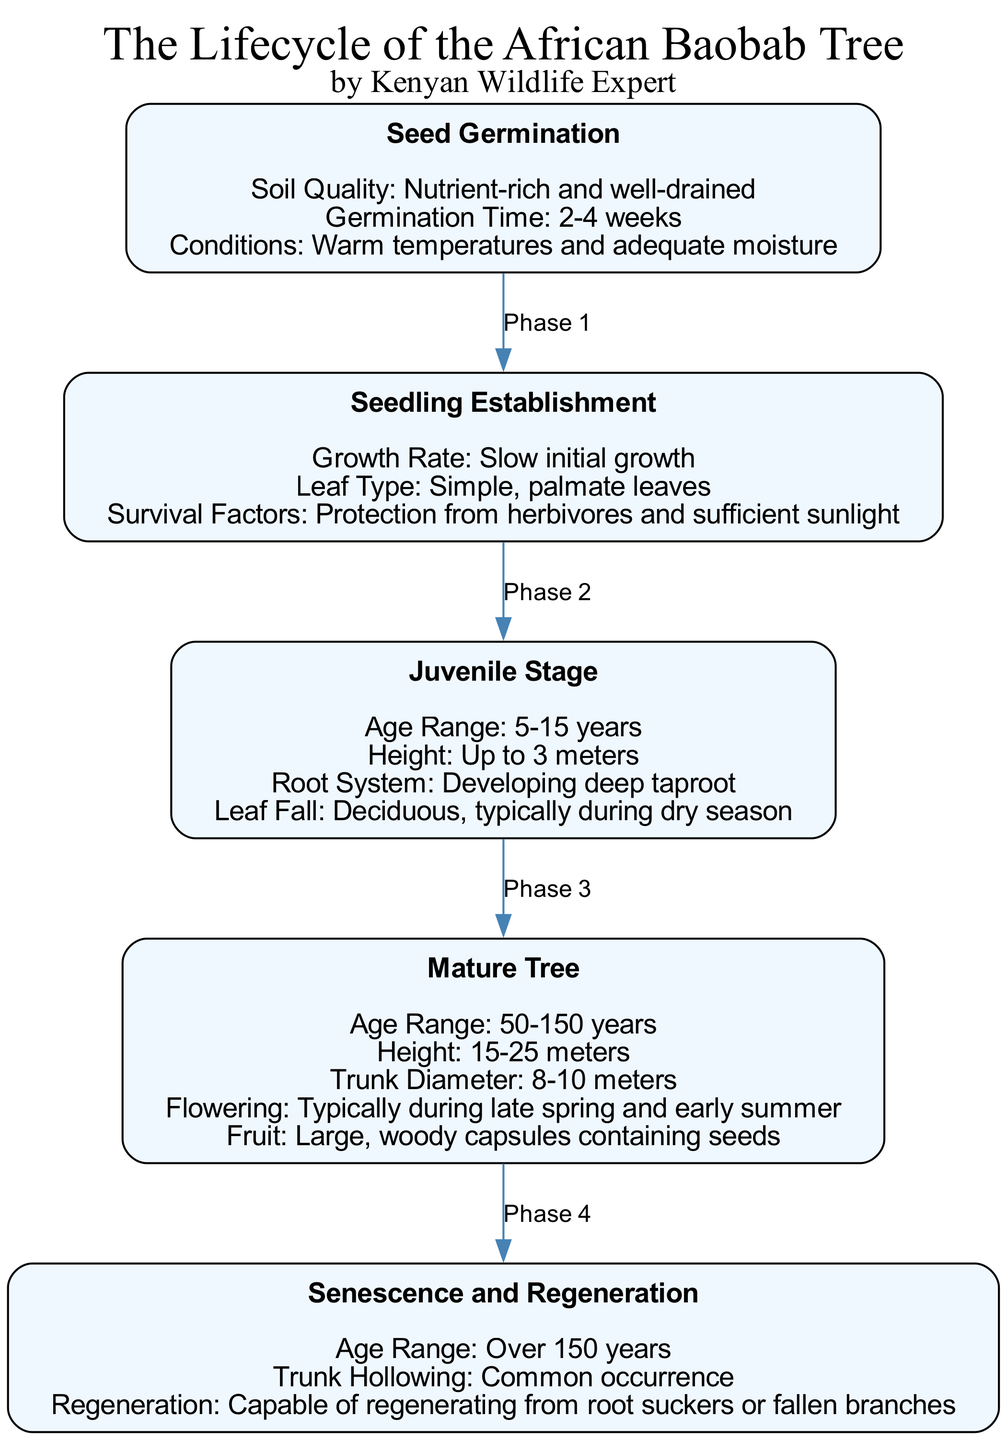What is the age range for the Juvenile Stage? The diagram specifies the age range for the Juvenile Stage as 5-15 years. This can be found directly within the details of the corresponding node.
Answer: 5-15 years What type of leaves does a Seedling have? According to the diagram, the Seedling Establishment phase features simple, palmate leaves, which is directly stated in the details for that phase.
Answer: Simple, palmate leaves How tall can a Mature Tree grow? The height for a Mature Tree is indicated in the diagram as 15-25 meters, found under the details of the Mature Tree phase.
Answer: 15-25 meters What common phenomenon occurs when the tree reaches senescence? The diagram mentions that trunk hollowing is a common occurrence in the Senescence and Regeneration phase, which can be directly referenced from the details specified for that phase.
Answer: Common occurrence What survival factors are necessary for the Seedling Establishment? The diagram outlines the survival factors for the Seedling stage, highlighting the protection from herbivores and sufficient sunlight as vital for its establishment. This information is stated clearly in the details section of the Seedling Establishment phase.
Answer: Protection from herbivores and sufficient sunlight Which phase involves flowering? The phase that involves flowering is the Mature Tree phase, as indicated in the diagram, where it specifies that flowering typically occurs during late spring and early summer.
Answer: Mature Tree Between which two phases does the growth of a tree from 3 meters to 15-25 meters occur? By reviewing the diagram, we can see that the transition occurs between the Juvenile Stage (up to 3 meters) and the Mature Tree phase (15-25 meters), revealing the increase in height as the tree matures.
Answer: Juvenile Stage and Mature Tree What is the germination time for the seed? The germination time for the seed is stated as 2-4 weeks in the Seed Germination phase, which is directly sourced from the details section of that node.
Answer: 2-4 weeks How does the African Baobab tree regenerate after senescence? The regeneration process after senescence is explained in the details of the Senescence and Regeneration phase, stating that it is capable of regenerating from root suckers or fallen branches, which showcases its resilience.
Answer: Capable of regenerating from root suckers or fallen branches 